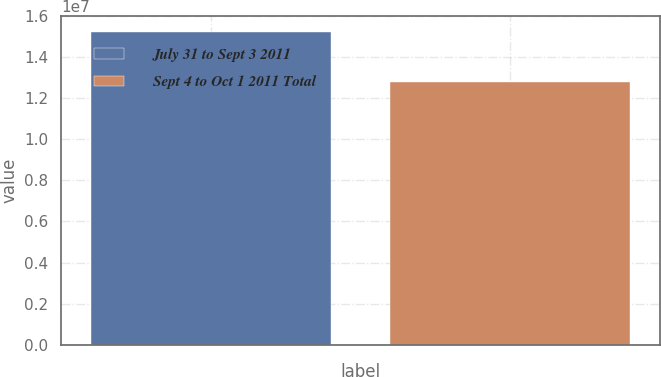Convert chart to OTSL. <chart><loc_0><loc_0><loc_500><loc_500><bar_chart><fcel>July 31 to Sept 3 2011<fcel>Sept 4 to Oct 1 2011 Total<nl><fcel>1.52636e+07<fcel>1.27938e+07<nl></chart> 